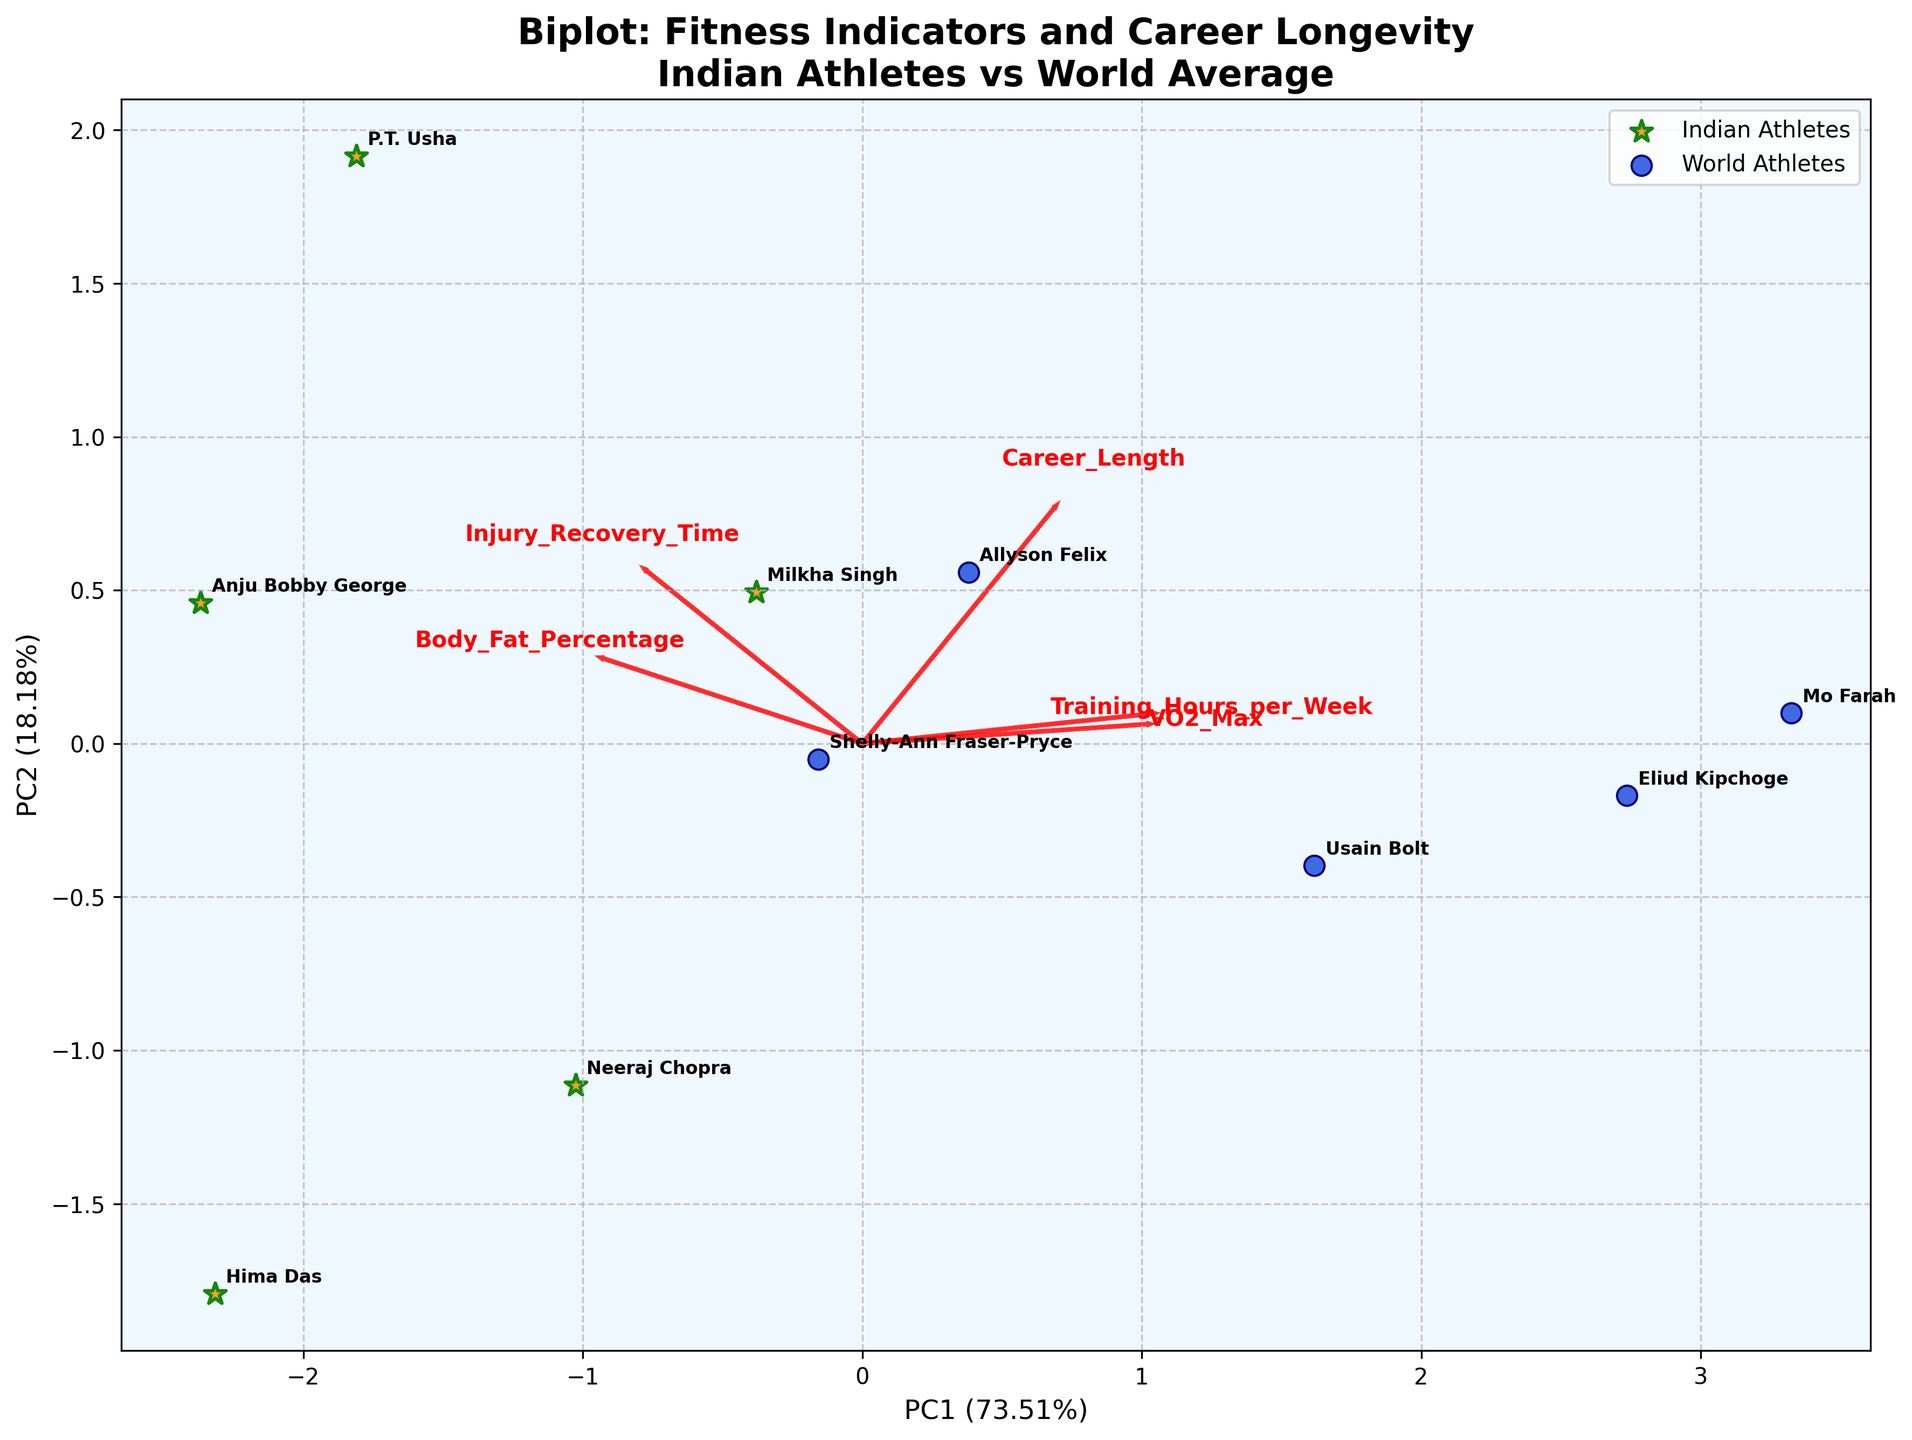what is the title of the biplot? The title of the Biplot is displayed at the top center of the figure, above all the points, arrows, and labels. It reads "Biplot: Fitness Indicators and Career Longevity\nIndian Athletes vs World Average".
Answer: Biplot: Fitness Indicators and Career Longevity\nIndian Athletes vs World Average How are Indian athletes differentiated visually from world athletes in the plot? Indian athletes are represented by star-shaped markers with an orange color and green edges, while world athletes are represented by circular markers with a blue color and dark blue edges.
Answer: By star-shaped markers and orange color How many features are being represented in the biplot? The number of features is determined by counting the number of red arrows in the plot. Each arrow represents a different feature.
Answer: 5 Which feature has the highest loading on the first principal component (PC1)? To determine which feature has the highest loading on PC1, observe the arrows and see which arrow extends the farthest along the x-axis (PC1).
Answer: VO2_Max How does Shelly-Ann Fraser-Pryce’s position relate to the features? Shelly-Ann Fraser-Pryce’s position in the biplot is relatively farther along the direction of the arrows for "Career_Length" and "VO2_Max" and closer to the center for "Body_Fat_Percentage" and "Injury_Recovery_Time".
Answer: High Career_Length and VO2_Max Are Indian athletes clustered together or dispersed compared to world athletes? By looking at the groups of markers, we can see whether the stars representing Indian athletes are placed closer to each other or scattered more widely compared to the circles representing world athletes.
Answer: Clustered Which two athletes are the closest in the biplot? To find the closest athletes, look for the pair of markers that are located nearest to each other.
Answer: Usain Bolt and Allyson Felix Which Indian athlete has the highest VO2 Max according to the biplot? To determine this, identify which Indian athlete's star marker is positioned furthest in the direction of the "VO2_Max" arrow.
Answer: P.T. Usha Between "Training_Hours_per_Week" and "Injury_Recovery_Time," which feature is more aligned with the second principal component (PC2)? Compare the direction of the arrows for these features concerning the y-axis (PC2). The feature with an arrow pointing more vertically (upwards or downwards) is more aligned with PC2.
Answer: Training_Hours_per_Week How are "Body_Fat_Percentage" and "VO2_Max" related based on the biplot? Analyze the directions of the arrows for "Body_Fat_Percentage" and "VO2_Max". If they point in opposite directions, they have a negative relationship; if they point in the same direction, they have a positive relationship.
Answer: Negative relationship 